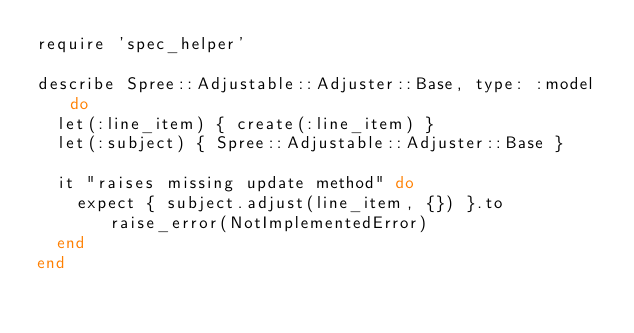Convert code to text. <code><loc_0><loc_0><loc_500><loc_500><_Ruby_>require 'spec_helper'

describe Spree::Adjustable::Adjuster::Base, type: :model do
  let(:line_item) { create(:line_item) }
  let(:subject) { Spree::Adjustable::Adjuster::Base }

  it "raises missing update method" do
    expect { subject.adjust(line_item, {}) }.to raise_error(NotImplementedError)
  end
end
</code> 